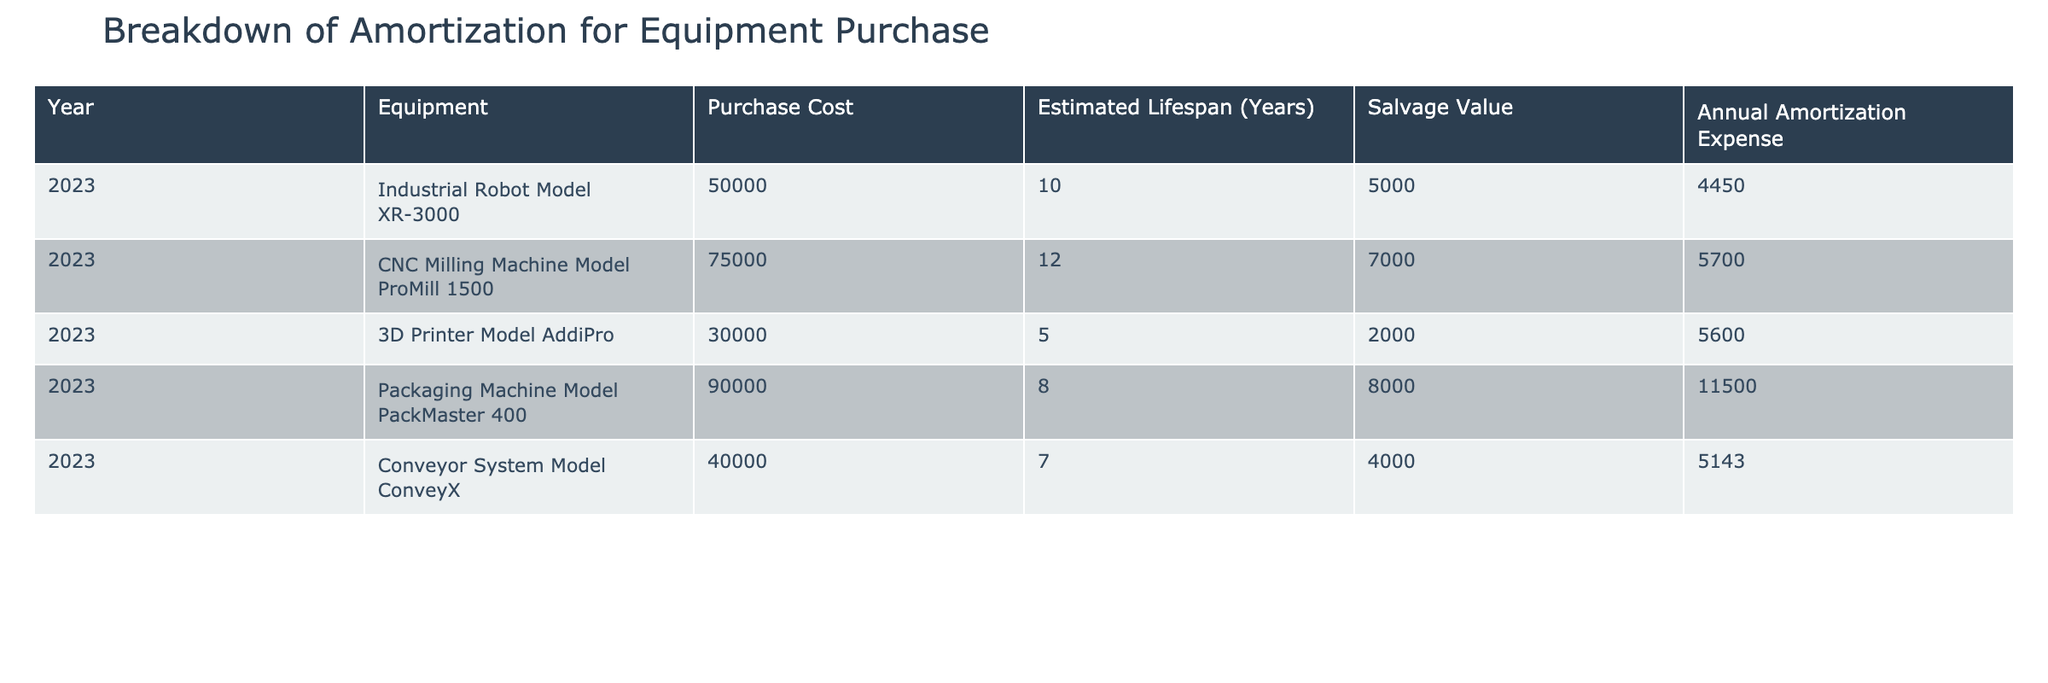What is the purchase cost of the CNC Milling Machine Model ProMill 1500? The table directly lists the "Purchase Cost" for the CNC Milling Machine Model ProMill 1500 as 75000.
Answer: 75000 What is the estimated lifespan of the Industrial Robot Model XR-3000? The table provides the estimated lifespan for the Industrial Robot Model XR-3000, which is 10 years.
Answer: 10 years Which equipment has the highest annual amortization expense? By comparing the "Annual Amortization Expense" column, the Packaging Machine Model PackMaster 400 has the highest value at 11500.
Answer: Packaging Machine Model PackMaster 400 What is the total annual amortization expense for all the equipment? To find the total, we sum the annual amortization expenses for all pieces of equipment: 4450 + 5700 + 5600 + 11500 + 5143 = 33993.
Answer: 33993 Is the salvage value of the 3D Printer Model AddiPro greater than its purchase cost? The table shows a purchase cost of 30000 and a salvage value of 2000, which indicates the salvage value is less than the purchase cost.
Answer: No Do any of the equipment have an estimated lifespan of less than 8 years? By checking the estimated lifespan, both the 3D Printer Model AddiPro (5 years) and the Conveyor System Model ConveyX (7 years) have lifespans less than 8 years.
Answer: Yes What is the difference in annual amortization expense between the most expensive and least expensive equipment? The most expensive annual amortization expense is from the Packaging Machine Model PackMaster 400 (11500), and the least is from the Industrial Robot Model XR-3000 (4450). The difference is 11500 - 4450 = 7050.
Answer: 7050 Which equipment has the smallest annual amortization expense, and what is its value? The Industrial Robot Model XR-3000 has the smallest annual amortization expense listed as 4450 in the table.
Answer: Industrial Robot Model XR-3000, 4450 How does the average annual amortization expense compare to the maximum expense? First, calculate the average by summing the annual expenses (33993) and dividing by the number of equipment (5): 33993 / 5 = 6798.6. The maximum expense is 11500. Since 6798.6 is less than 11500, the average is lower.
Answer: Average is lower 